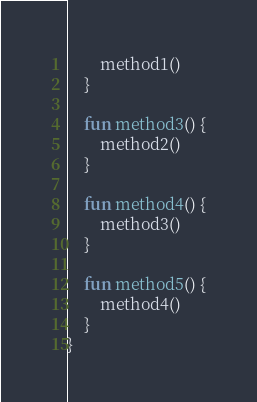Convert code to text. <code><loc_0><loc_0><loc_500><loc_500><_Kotlin_>        method1()
    }

    fun method3() {
        method2()
    }

    fun method4() {
        method3()
    }

    fun method5() {
        method4()
    }
}
</code> 